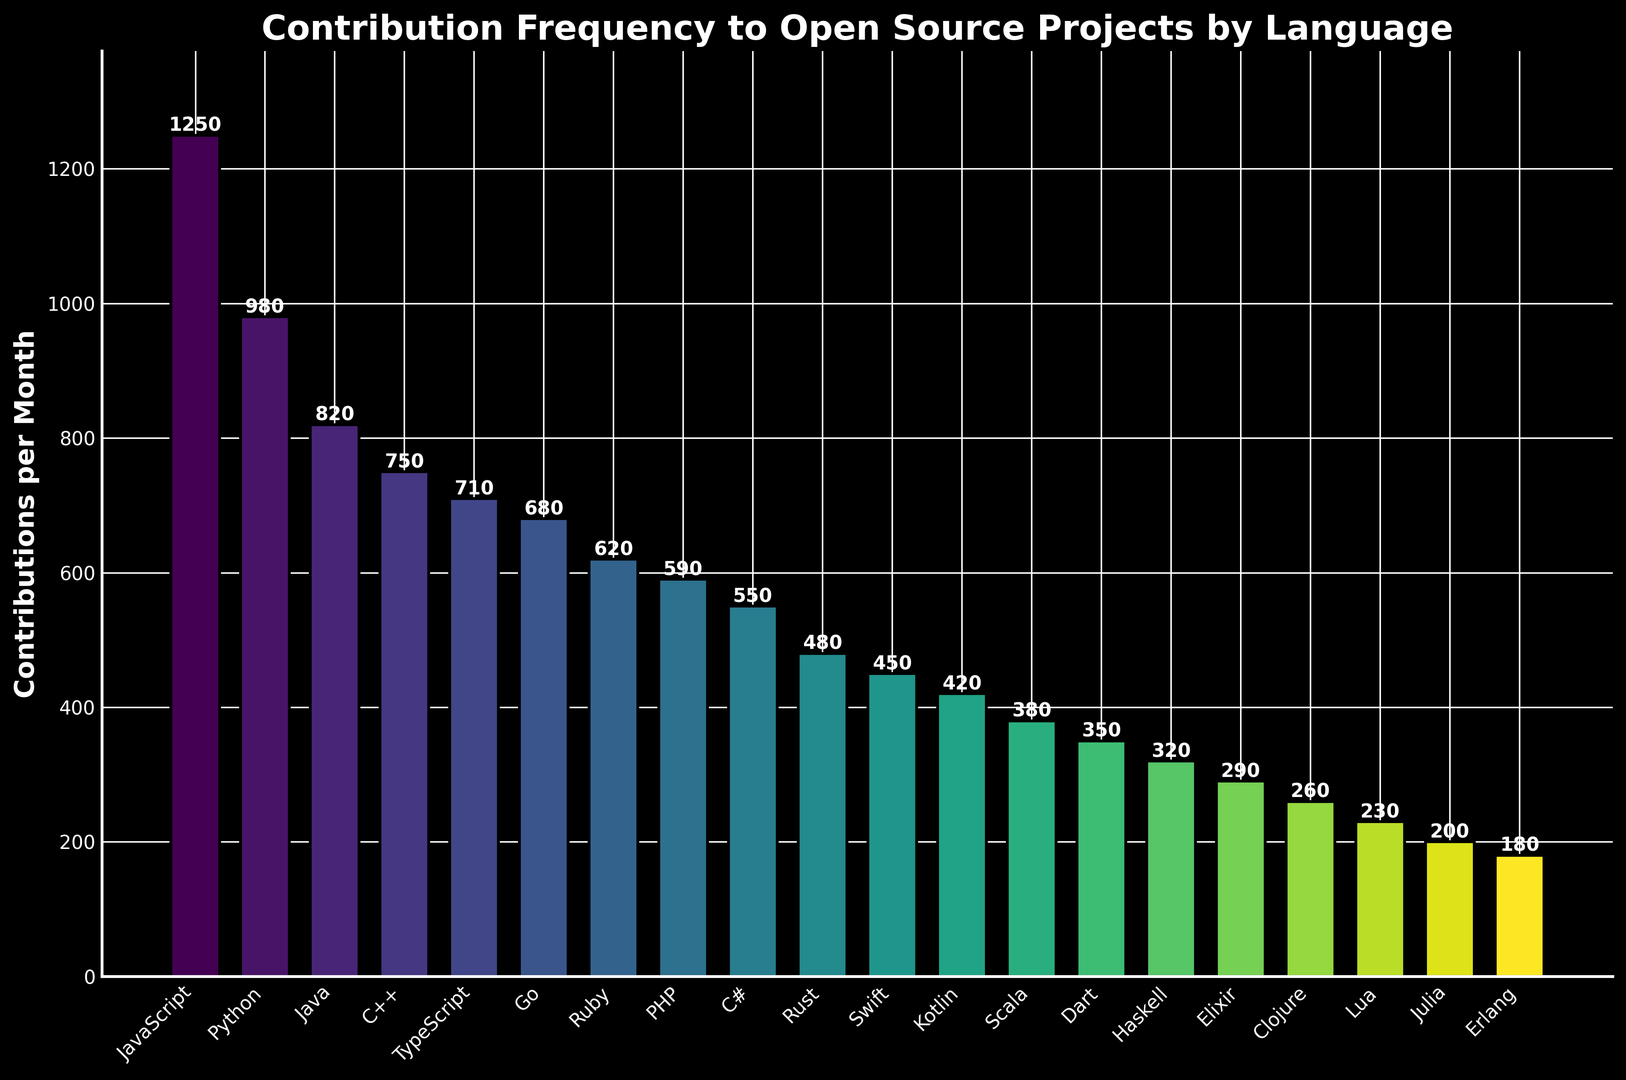What's the language with the highest contribution count? The tallest bar represents the language with the highest contributions. It corresponds to JavaScript, with 1250 contributions per month.
Answer: JavaScript Which language has fewer contributions, Ruby or PHP? Locate the bars for Ruby and PHP. Compare their heights. Ruby has 620 contributions, while PHP has 590, making PHP have fewer contributions.
Answer: PHP Between C++ and Go, which language has more contributions, and by how much? Identify the bars for C++ and Go. C++ has 750 contributions and Go has 680. The difference is 750 - 680 = 70 contributions.
Answer: C++ by 70 What's the sum of contributions for the top three languages? The top three languages are JavaScript (1250), Python (980), and Java (820). Sum them: 1250 + 980 + 820 = 3050.
Answer: 3050 What's the average contribution count for TypeScript, Rust, and Swift? TypeScript has 710, Rust has 480, and Swift has 450 contributions. The average is (710 + 480 + 450)/3 = 540 contributions.
Answer: 540 Are there more contributions for C# or Kotlin, and by how much? Locate the bars for C# and Kotlin. C# has 550 contributions, while Kotlin has 420. The difference is 550 - 420 = 130 contributions.
Answer: C# by 130 What is the median contribution count for all languages? Arrange all contributions in ascending order: 180, 200, 230, 260, 290, 320, 350, 380, 420, 450, 480, 550, 590, 620, 680, 710, 750, 820, 980, 1250. The median is the middle value, so (450 + 480)/2 = 465 contributions.
Answer: 465 Which three languages have the lowest contribution counts? The shortest bars indicate the languages with the lowest contributions. Identify Erlang (180), Julia (200), and Lua (230).
Answer: Erlang, Julia, and Lua What's the difference in contributions between the language with the highest and the lowest contributions? JavaScript has the highest contributions at 1250, and Erlang has the lowest at 180. The difference is 1250 - 180 = 1070 contributions.
Answer: 1070 Which language has slightly fewer contributions than Go? Identify the bar for Go with 680 contributions, and then locate the next shortest bar, which corresponds to TypeScript with 710 contributions.
Answer: TypeScript 